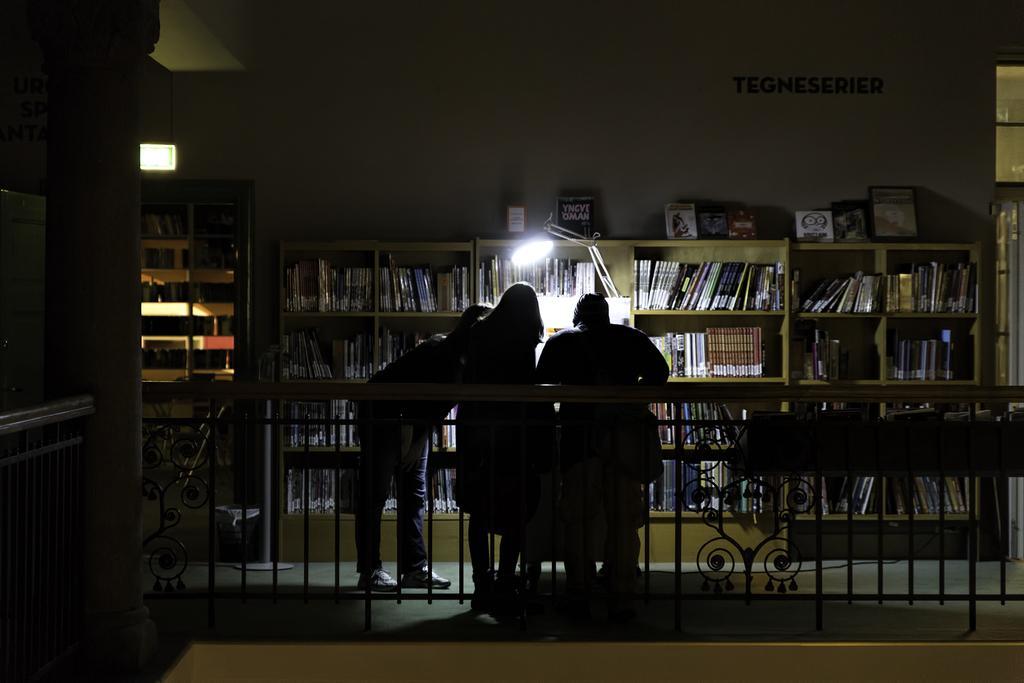Could you give a brief overview of what you see in this image? In front of the image there is a metal rod fence with a pillar, behind the pillar there are a few people standing. In front of them there are books on the bookshelves. On top of the wall there is some text. 